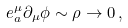<formula> <loc_0><loc_0><loc_500><loc_500>e _ { a } ^ { \mu } \partial _ { \mu } \phi \sim \rho \rightarrow 0 \, ,</formula> 